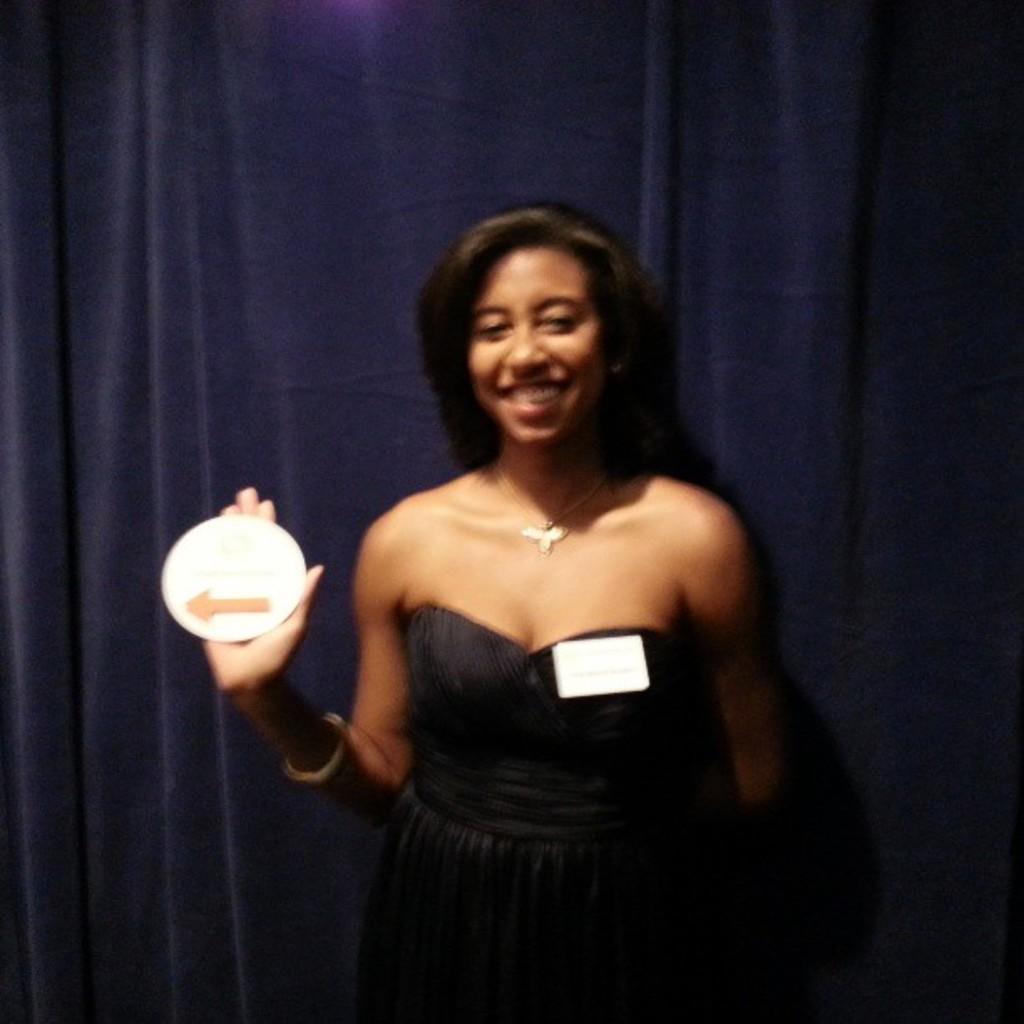In one or two sentences, can you explain what this image depicts? In this image I can see a woman wearing black dress is standing and holding a white colored paper in her hand. I can see a white colored object sticked to her dress. In the background I can see the curtain. 